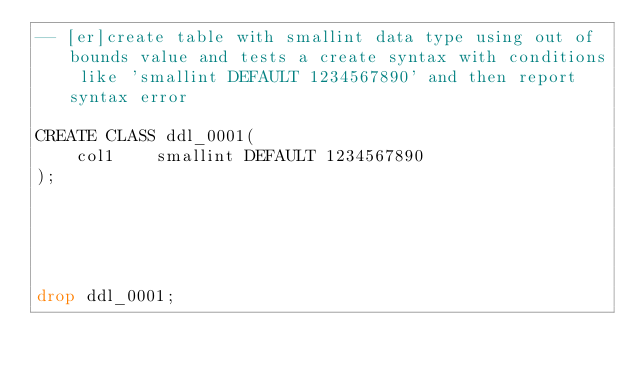<code> <loc_0><loc_0><loc_500><loc_500><_SQL_>-- [er]create table with smallint data type using out of bounds value and tests a create syntax with conditions like 'smallint DEFAULT 1234567890' and then report syntax error

CREATE CLASS ddl_0001(
    col1    smallint DEFAULT 1234567890
);





drop ddl_0001;</code> 